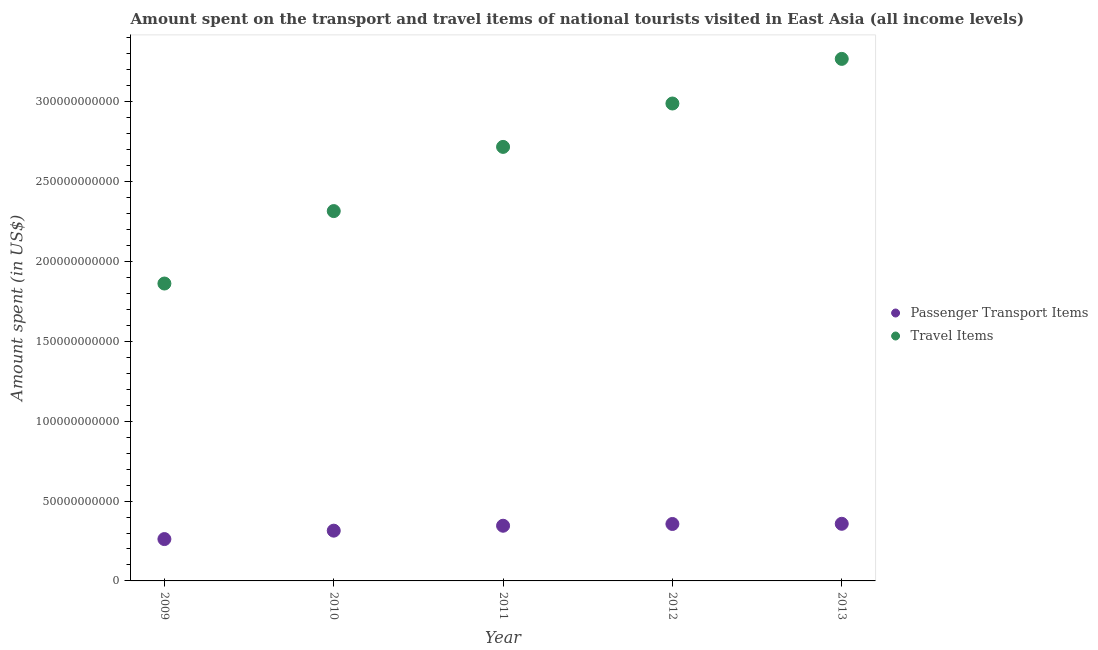How many different coloured dotlines are there?
Give a very brief answer. 2. What is the amount spent on passenger transport items in 2012?
Keep it short and to the point. 3.57e+1. Across all years, what is the maximum amount spent in travel items?
Offer a very short reply. 3.27e+11. Across all years, what is the minimum amount spent in travel items?
Your answer should be compact. 1.86e+11. In which year was the amount spent on passenger transport items maximum?
Make the answer very short. 2013. In which year was the amount spent in travel items minimum?
Offer a terse response. 2009. What is the total amount spent in travel items in the graph?
Give a very brief answer. 1.32e+12. What is the difference between the amount spent on passenger transport items in 2010 and that in 2011?
Offer a terse response. -3.08e+09. What is the difference between the amount spent on passenger transport items in 2012 and the amount spent in travel items in 2009?
Your response must be concise. -1.51e+11. What is the average amount spent in travel items per year?
Offer a terse response. 2.63e+11. In the year 2013, what is the difference between the amount spent on passenger transport items and amount spent in travel items?
Give a very brief answer. -2.91e+11. What is the ratio of the amount spent on passenger transport items in 2010 to that in 2012?
Provide a succinct answer. 0.88. Is the difference between the amount spent in travel items in 2010 and 2013 greater than the difference between the amount spent on passenger transport items in 2010 and 2013?
Ensure brevity in your answer.  No. What is the difference between the highest and the second highest amount spent on passenger transport items?
Provide a short and direct response. 1.12e+08. What is the difference between the highest and the lowest amount spent on passenger transport items?
Offer a terse response. 9.57e+09. Is the sum of the amount spent in travel items in 2009 and 2010 greater than the maximum amount spent on passenger transport items across all years?
Give a very brief answer. Yes. Does the amount spent on passenger transport items monotonically increase over the years?
Your answer should be compact. Yes. Is the amount spent on passenger transport items strictly greater than the amount spent in travel items over the years?
Your response must be concise. No. How many dotlines are there?
Offer a terse response. 2. What is the difference between two consecutive major ticks on the Y-axis?
Your answer should be compact. 5.00e+1. Are the values on the major ticks of Y-axis written in scientific E-notation?
Give a very brief answer. No. Does the graph contain any zero values?
Offer a terse response. No. Does the graph contain grids?
Your answer should be compact. No. How are the legend labels stacked?
Your answer should be very brief. Vertical. What is the title of the graph?
Offer a terse response. Amount spent on the transport and travel items of national tourists visited in East Asia (all income levels). What is the label or title of the Y-axis?
Make the answer very short. Amount spent (in US$). What is the Amount spent (in US$) of Passenger Transport Items in 2009?
Your answer should be compact. 2.62e+1. What is the Amount spent (in US$) in Travel Items in 2009?
Your answer should be compact. 1.86e+11. What is the Amount spent (in US$) of Passenger Transport Items in 2010?
Your response must be concise. 3.15e+1. What is the Amount spent (in US$) of Travel Items in 2010?
Offer a very short reply. 2.32e+11. What is the Amount spent (in US$) in Passenger Transport Items in 2011?
Keep it short and to the point. 3.46e+1. What is the Amount spent (in US$) in Travel Items in 2011?
Your answer should be very brief. 2.72e+11. What is the Amount spent (in US$) in Passenger Transport Items in 2012?
Give a very brief answer. 3.57e+1. What is the Amount spent (in US$) of Travel Items in 2012?
Make the answer very short. 2.99e+11. What is the Amount spent (in US$) of Passenger Transport Items in 2013?
Make the answer very short. 3.58e+1. What is the Amount spent (in US$) of Travel Items in 2013?
Offer a terse response. 3.27e+11. Across all years, what is the maximum Amount spent (in US$) of Passenger Transport Items?
Your answer should be compact. 3.58e+1. Across all years, what is the maximum Amount spent (in US$) in Travel Items?
Provide a succinct answer. 3.27e+11. Across all years, what is the minimum Amount spent (in US$) in Passenger Transport Items?
Your answer should be very brief. 2.62e+1. Across all years, what is the minimum Amount spent (in US$) of Travel Items?
Make the answer very short. 1.86e+11. What is the total Amount spent (in US$) of Passenger Transport Items in the graph?
Your response must be concise. 1.64e+11. What is the total Amount spent (in US$) of Travel Items in the graph?
Your answer should be compact. 1.32e+12. What is the difference between the Amount spent (in US$) of Passenger Transport Items in 2009 and that in 2010?
Offer a terse response. -5.27e+09. What is the difference between the Amount spent (in US$) in Travel Items in 2009 and that in 2010?
Provide a succinct answer. -4.54e+1. What is the difference between the Amount spent (in US$) of Passenger Transport Items in 2009 and that in 2011?
Ensure brevity in your answer.  -8.35e+09. What is the difference between the Amount spent (in US$) in Travel Items in 2009 and that in 2011?
Your answer should be compact. -8.56e+1. What is the difference between the Amount spent (in US$) of Passenger Transport Items in 2009 and that in 2012?
Your answer should be very brief. -9.46e+09. What is the difference between the Amount spent (in US$) in Travel Items in 2009 and that in 2012?
Make the answer very short. -1.13e+11. What is the difference between the Amount spent (in US$) of Passenger Transport Items in 2009 and that in 2013?
Your answer should be compact. -9.57e+09. What is the difference between the Amount spent (in US$) in Travel Items in 2009 and that in 2013?
Make the answer very short. -1.41e+11. What is the difference between the Amount spent (in US$) of Passenger Transport Items in 2010 and that in 2011?
Keep it short and to the point. -3.08e+09. What is the difference between the Amount spent (in US$) in Travel Items in 2010 and that in 2011?
Give a very brief answer. -4.02e+1. What is the difference between the Amount spent (in US$) of Passenger Transport Items in 2010 and that in 2012?
Your answer should be compact. -4.19e+09. What is the difference between the Amount spent (in US$) in Travel Items in 2010 and that in 2012?
Ensure brevity in your answer.  -6.74e+1. What is the difference between the Amount spent (in US$) in Passenger Transport Items in 2010 and that in 2013?
Provide a succinct answer. -4.30e+09. What is the difference between the Amount spent (in US$) of Travel Items in 2010 and that in 2013?
Your response must be concise. -9.53e+1. What is the difference between the Amount spent (in US$) of Passenger Transport Items in 2011 and that in 2012?
Give a very brief answer. -1.11e+09. What is the difference between the Amount spent (in US$) in Travel Items in 2011 and that in 2012?
Offer a terse response. -2.72e+1. What is the difference between the Amount spent (in US$) of Passenger Transport Items in 2011 and that in 2013?
Offer a terse response. -1.22e+09. What is the difference between the Amount spent (in US$) of Travel Items in 2011 and that in 2013?
Ensure brevity in your answer.  -5.51e+1. What is the difference between the Amount spent (in US$) of Passenger Transport Items in 2012 and that in 2013?
Offer a very short reply. -1.12e+08. What is the difference between the Amount spent (in US$) of Travel Items in 2012 and that in 2013?
Keep it short and to the point. -2.79e+1. What is the difference between the Amount spent (in US$) of Passenger Transport Items in 2009 and the Amount spent (in US$) of Travel Items in 2010?
Give a very brief answer. -2.05e+11. What is the difference between the Amount spent (in US$) in Passenger Transport Items in 2009 and the Amount spent (in US$) in Travel Items in 2011?
Your response must be concise. -2.46e+11. What is the difference between the Amount spent (in US$) in Passenger Transport Items in 2009 and the Amount spent (in US$) in Travel Items in 2012?
Give a very brief answer. -2.73e+11. What is the difference between the Amount spent (in US$) in Passenger Transport Items in 2009 and the Amount spent (in US$) in Travel Items in 2013?
Provide a short and direct response. -3.01e+11. What is the difference between the Amount spent (in US$) of Passenger Transport Items in 2010 and the Amount spent (in US$) of Travel Items in 2011?
Ensure brevity in your answer.  -2.40e+11. What is the difference between the Amount spent (in US$) in Passenger Transport Items in 2010 and the Amount spent (in US$) in Travel Items in 2012?
Your answer should be very brief. -2.67e+11. What is the difference between the Amount spent (in US$) of Passenger Transport Items in 2010 and the Amount spent (in US$) of Travel Items in 2013?
Give a very brief answer. -2.95e+11. What is the difference between the Amount spent (in US$) of Passenger Transport Items in 2011 and the Amount spent (in US$) of Travel Items in 2012?
Give a very brief answer. -2.64e+11. What is the difference between the Amount spent (in US$) in Passenger Transport Items in 2011 and the Amount spent (in US$) in Travel Items in 2013?
Your answer should be compact. -2.92e+11. What is the difference between the Amount spent (in US$) of Passenger Transport Items in 2012 and the Amount spent (in US$) of Travel Items in 2013?
Your response must be concise. -2.91e+11. What is the average Amount spent (in US$) of Passenger Transport Items per year?
Keep it short and to the point. 3.27e+1. What is the average Amount spent (in US$) in Travel Items per year?
Your answer should be very brief. 2.63e+11. In the year 2009, what is the difference between the Amount spent (in US$) in Passenger Transport Items and Amount spent (in US$) in Travel Items?
Make the answer very short. -1.60e+11. In the year 2010, what is the difference between the Amount spent (in US$) of Passenger Transport Items and Amount spent (in US$) of Travel Items?
Provide a short and direct response. -2.00e+11. In the year 2011, what is the difference between the Amount spent (in US$) in Passenger Transport Items and Amount spent (in US$) in Travel Items?
Your response must be concise. -2.37e+11. In the year 2012, what is the difference between the Amount spent (in US$) in Passenger Transport Items and Amount spent (in US$) in Travel Items?
Offer a terse response. -2.63e+11. In the year 2013, what is the difference between the Amount spent (in US$) of Passenger Transport Items and Amount spent (in US$) of Travel Items?
Provide a succinct answer. -2.91e+11. What is the ratio of the Amount spent (in US$) of Passenger Transport Items in 2009 to that in 2010?
Provide a short and direct response. 0.83. What is the ratio of the Amount spent (in US$) of Travel Items in 2009 to that in 2010?
Offer a very short reply. 0.8. What is the ratio of the Amount spent (in US$) in Passenger Transport Items in 2009 to that in 2011?
Offer a terse response. 0.76. What is the ratio of the Amount spent (in US$) of Travel Items in 2009 to that in 2011?
Your answer should be very brief. 0.69. What is the ratio of the Amount spent (in US$) of Passenger Transport Items in 2009 to that in 2012?
Offer a very short reply. 0.73. What is the ratio of the Amount spent (in US$) in Travel Items in 2009 to that in 2012?
Provide a succinct answer. 0.62. What is the ratio of the Amount spent (in US$) of Passenger Transport Items in 2009 to that in 2013?
Keep it short and to the point. 0.73. What is the ratio of the Amount spent (in US$) of Travel Items in 2009 to that in 2013?
Offer a very short reply. 0.57. What is the ratio of the Amount spent (in US$) in Passenger Transport Items in 2010 to that in 2011?
Give a very brief answer. 0.91. What is the ratio of the Amount spent (in US$) in Travel Items in 2010 to that in 2011?
Your response must be concise. 0.85. What is the ratio of the Amount spent (in US$) in Passenger Transport Items in 2010 to that in 2012?
Offer a very short reply. 0.88. What is the ratio of the Amount spent (in US$) of Travel Items in 2010 to that in 2012?
Your answer should be compact. 0.77. What is the ratio of the Amount spent (in US$) of Passenger Transport Items in 2010 to that in 2013?
Give a very brief answer. 0.88. What is the ratio of the Amount spent (in US$) of Travel Items in 2010 to that in 2013?
Your response must be concise. 0.71. What is the ratio of the Amount spent (in US$) in Passenger Transport Items in 2011 to that in 2013?
Give a very brief answer. 0.97. What is the ratio of the Amount spent (in US$) of Travel Items in 2011 to that in 2013?
Provide a short and direct response. 0.83. What is the ratio of the Amount spent (in US$) of Travel Items in 2012 to that in 2013?
Provide a succinct answer. 0.91. What is the difference between the highest and the second highest Amount spent (in US$) of Passenger Transport Items?
Provide a succinct answer. 1.12e+08. What is the difference between the highest and the second highest Amount spent (in US$) in Travel Items?
Your answer should be compact. 2.79e+1. What is the difference between the highest and the lowest Amount spent (in US$) in Passenger Transport Items?
Your answer should be very brief. 9.57e+09. What is the difference between the highest and the lowest Amount spent (in US$) of Travel Items?
Give a very brief answer. 1.41e+11. 